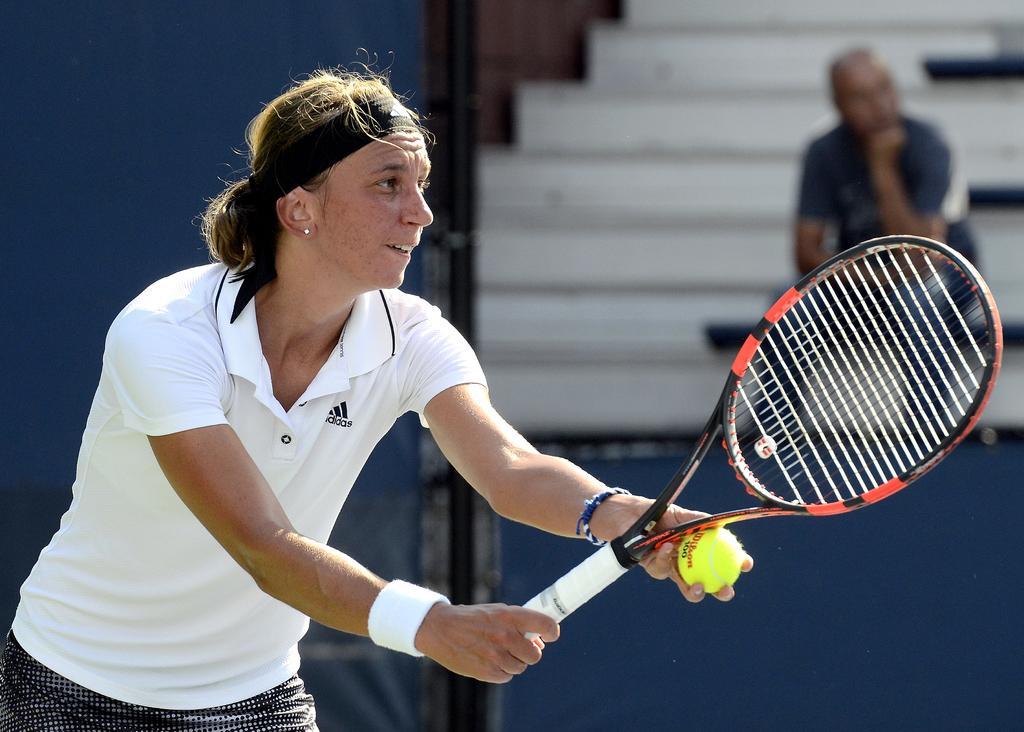How would you summarize this image in a sentence or two? In this image there is a person standing and holding a tennis racket and a ball , and in the background there is another person sitting. 